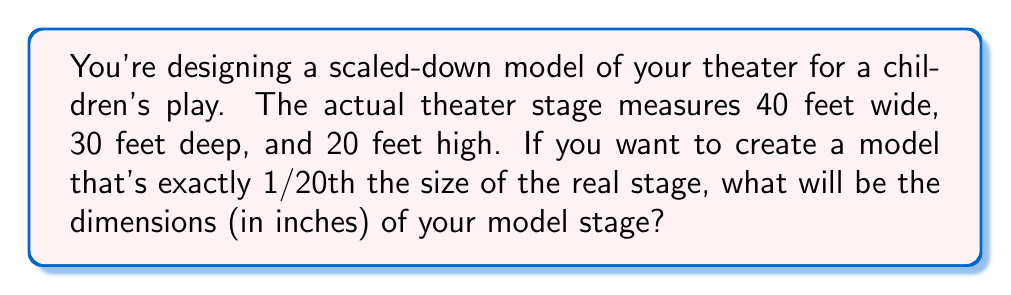Show me your answer to this math problem. To solve this problem, we need to follow these steps:

1. Understand the scale factor:
   The model is 1/20th the size of the real stage, so our scale factor is 1/20 or 0.05.

2. Convert the original dimensions from feet to inches:
   $$ 40 \text{ feet} \times 12 \text{ inches/foot} = 480 \text{ inches} $$
   $$ 30 \text{ feet} \times 12 \text{ inches/foot} = 360 \text{ inches} $$
   $$ 20 \text{ feet} \times 12 \text{ inches/foot} = 240 \text{ inches} $$

3. Apply the scale factor to each dimension:
   Width: $480 \text{ inches} \times 0.05 = 24 \text{ inches}$
   Depth: $360 \text{ inches} \times 0.05 = 18 \text{ inches}$
   Height: $240 \text{ inches} \times 0.05 = 12 \text{ inches}$

Therefore, the dimensions of the scaled-down model theater will be 24 inches wide, 18 inches deep, and 12 inches high.
Answer: The dimensions of the model stage will be 24 inches wide, 18 inches deep, and 12 inches high. 